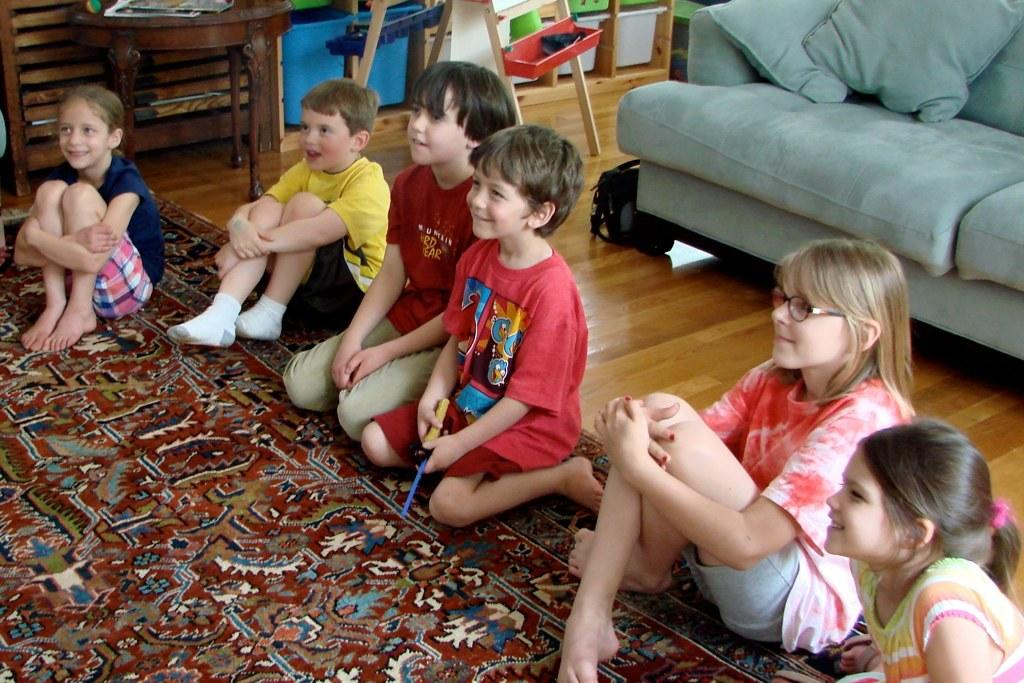How many children are in the image? There is a group of children in the image, but the exact number is not specified. What are the children sitting on? The children are sitting on a carpet. What are the children doing while sitting on the carpet? The children are listening to something. What type of cherry is being rubbed in the bubble in the image? There is no cherry, bubble, or rubbing action present in the image. 